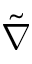<formula> <loc_0><loc_0><loc_500><loc_500>\tilde { \nabla }</formula> 